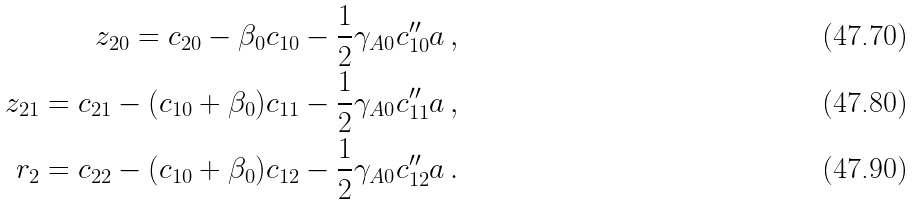<formula> <loc_0><loc_0><loc_500><loc_500>z _ { 2 0 } = c _ { 2 0 } - \beta _ { 0 } c _ { 1 0 } - \frac { 1 } { 2 } \gamma _ { A 0 } c _ { 1 0 } ^ { \prime \prime } a \, , \\ z _ { 2 1 } = c _ { 2 1 } - ( c _ { 1 0 } + \beta _ { 0 } ) c _ { 1 1 } - \frac { 1 } { 2 } \gamma _ { A 0 } c _ { 1 1 } ^ { \prime \prime } a \, , \\ r _ { 2 } = c _ { 2 2 } - ( c _ { 1 0 } + \beta _ { 0 } ) c _ { 1 2 } - \frac { 1 } { 2 } \gamma _ { A 0 } c _ { 1 2 } ^ { \prime \prime } a \, .</formula> 